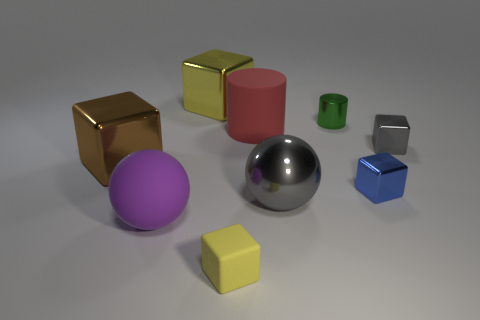Subtract all tiny metallic cubes. How many cubes are left? 3 Add 1 metallic cylinders. How many objects exist? 10 Subtract all blue blocks. How many blocks are left? 4 Subtract all balls. How many objects are left? 7 Subtract all cyan spheres. How many yellow cubes are left? 2 Subtract all red spheres. Subtract all blue blocks. How many spheres are left? 2 Subtract all large gray balls. Subtract all cubes. How many objects are left? 3 Add 9 red things. How many red things are left? 10 Add 3 gray metallic things. How many gray metallic things exist? 5 Subtract 0 blue cylinders. How many objects are left? 9 